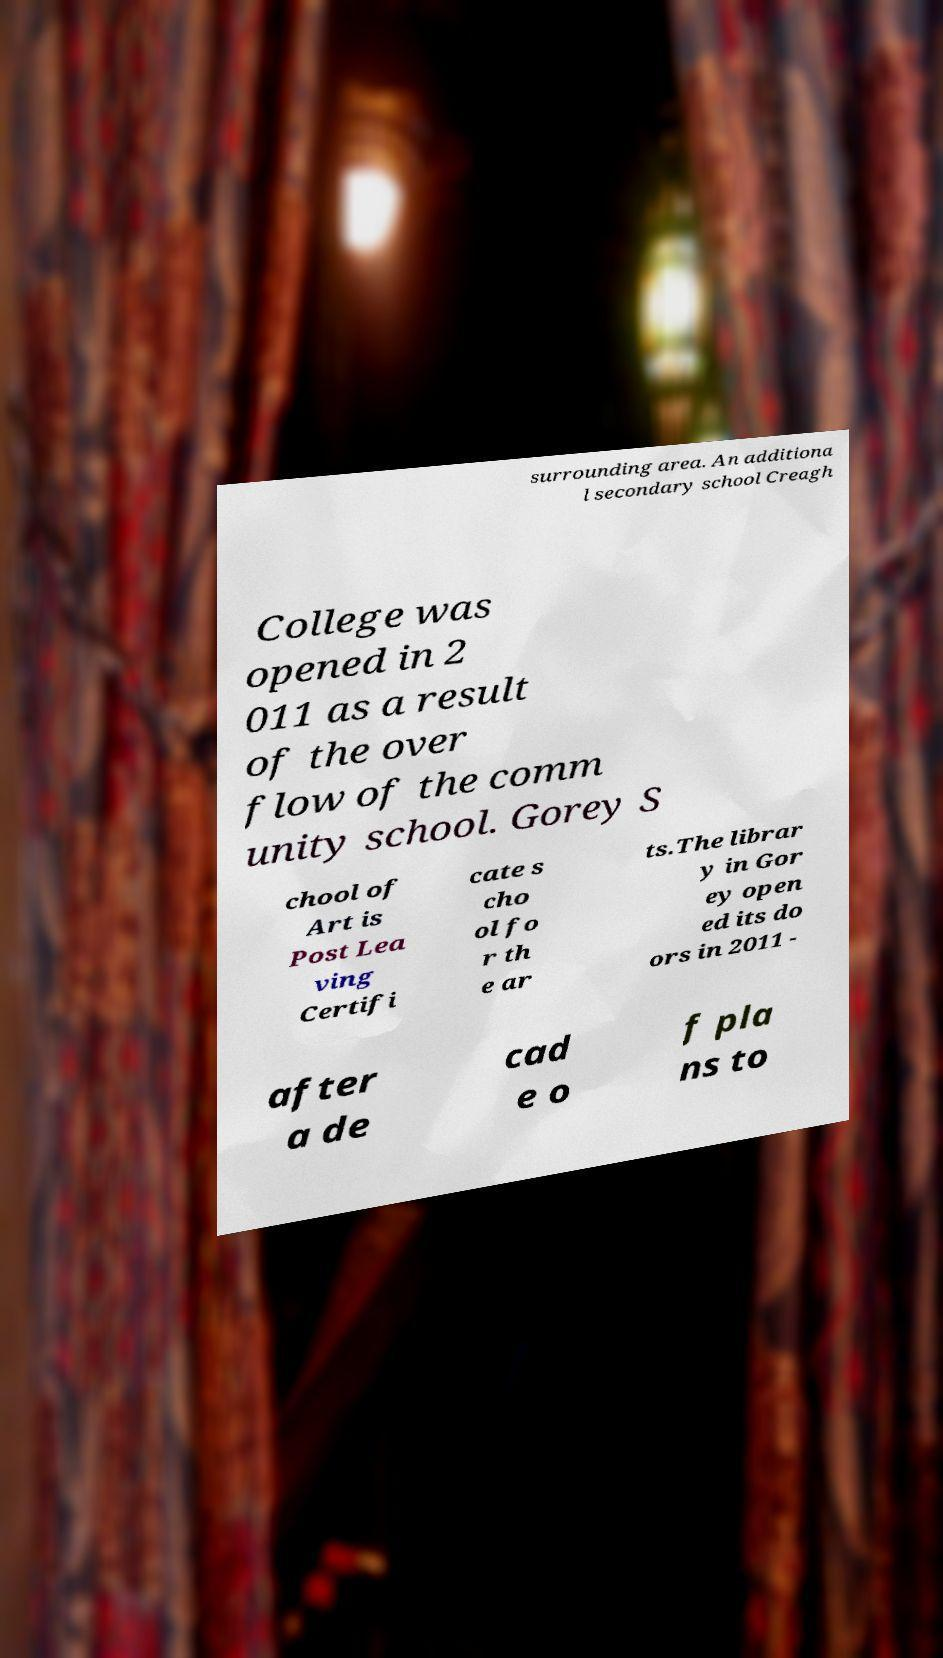What messages or text are displayed in this image? I need them in a readable, typed format. surrounding area. An additiona l secondary school Creagh College was opened in 2 011 as a result of the over flow of the comm unity school. Gorey S chool of Art is Post Lea ving Certifi cate s cho ol fo r th e ar ts.The librar y in Gor ey open ed its do ors in 2011 - after a de cad e o f pla ns to 